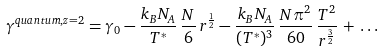Convert formula to latex. <formula><loc_0><loc_0><loc_500><loc_500>\gamma ^ { q u a n t u m , z = 2 } = \gamma _ { 0 } - \frac { k _ { B } N _ { A } } { T ^ { * } } \, \frac { N } { 6 } \, r ^ { \frac { 1 } { 2 } } - \frac { k _ { B } N _ { A } } { ( T ^ { * } ) ^ { 3 } } \, \frac { N \pi ^ { 2 } } { 6 0 } \, \frac { T ^ { 2 } } { r ^ { \frac { 3 } { 2 } } } \, + \, \dots</formula> 